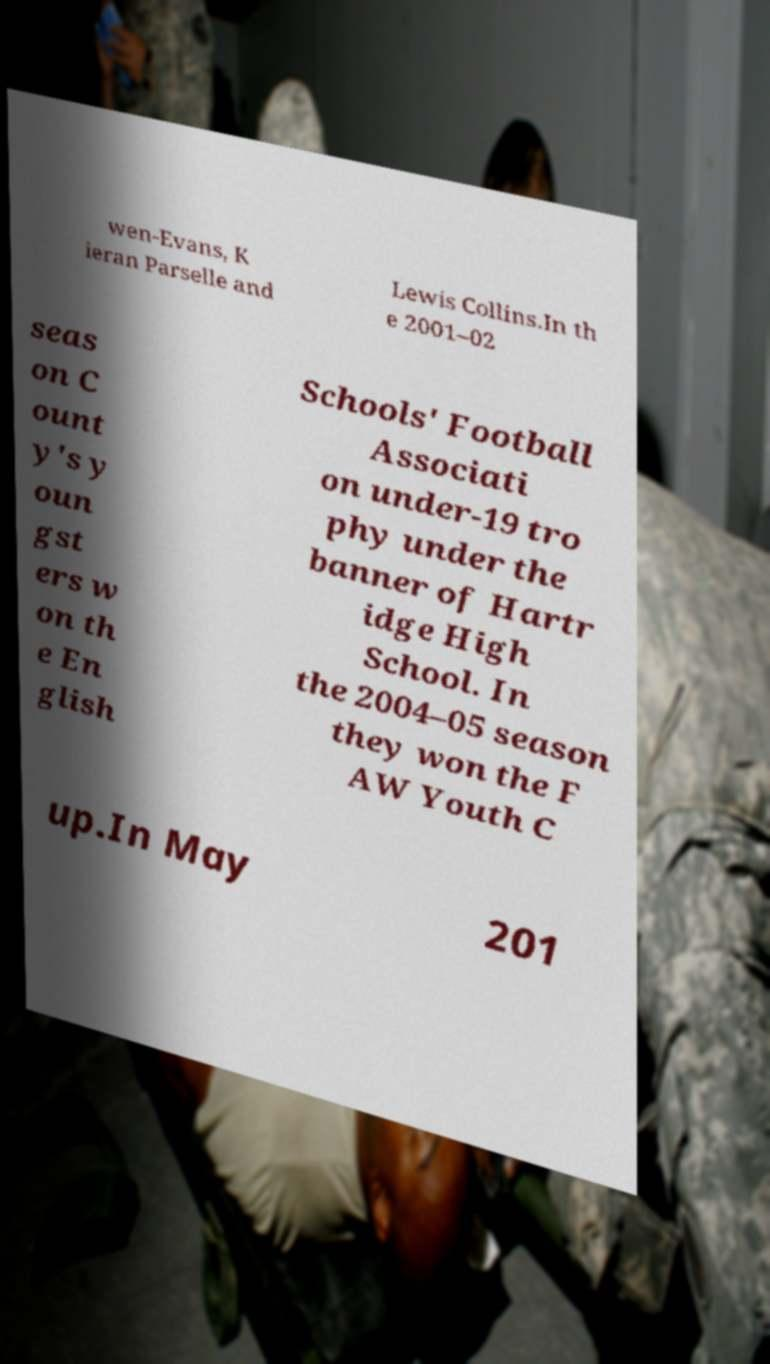For documentation purposes, I need the text within this image transcribed. Could you provide that? wen-Evans, K ieran Parselle and Lewis Collins.In th e 2001–02 seas on C ount y's y oun gst ers w on th e En glish Schools' Football Associati on under-19 tro phy under the banner of Hartr idge High School. In the 2004–05 season they won the F AW Youth C up.In May 201 